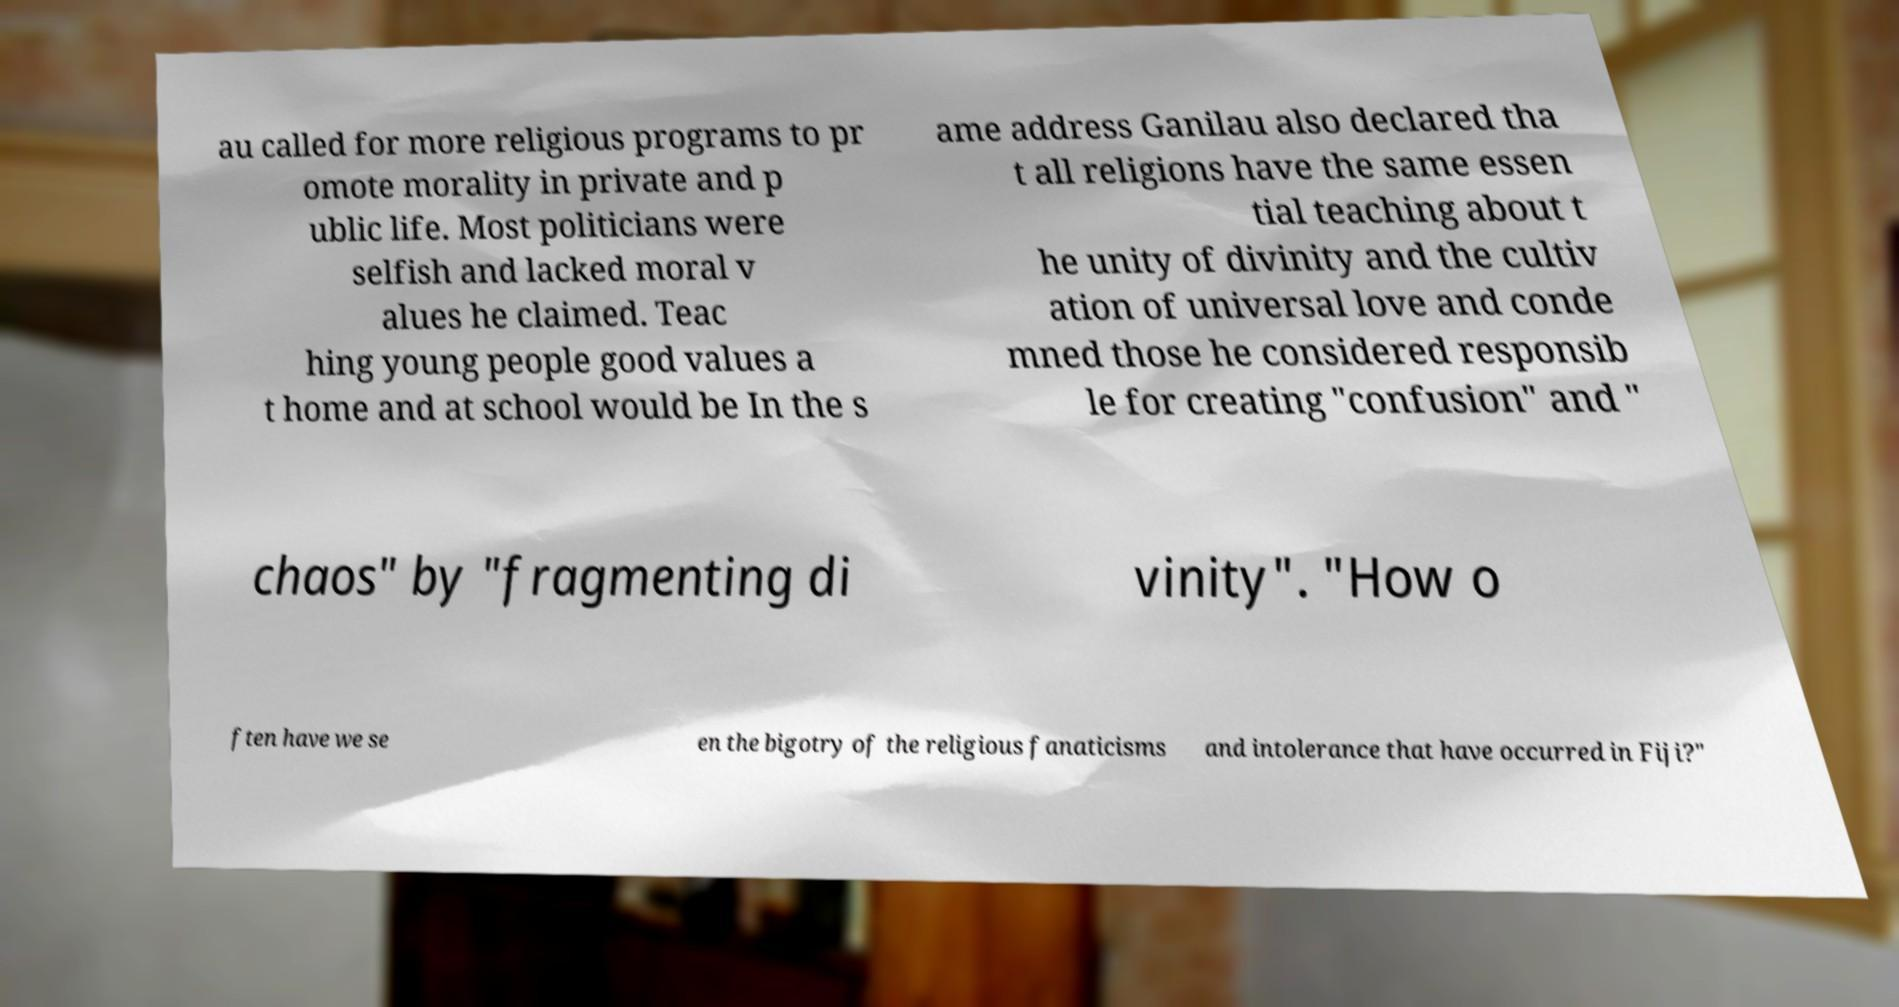Can you accurately transcribe the text from the provided image for me? au called for more religious programs to pr omote morality in private and p ublic life. Most politicians were selfish and lacked moral v alues he claimed. Teac hing young people good values a t home and at school would be In the s ame address Ganilau also declared tha t all religions have the same essen tial teaching about t he unity of divinity and the cultiv ation of universal love and conde mned those he considered responsib le for creating "confusion" and " chaos" by "fragmenting di vinity". "How o ften have we se en the bigotry of the religious fanaticisms and intolerance that have occurred in Fiji?" 